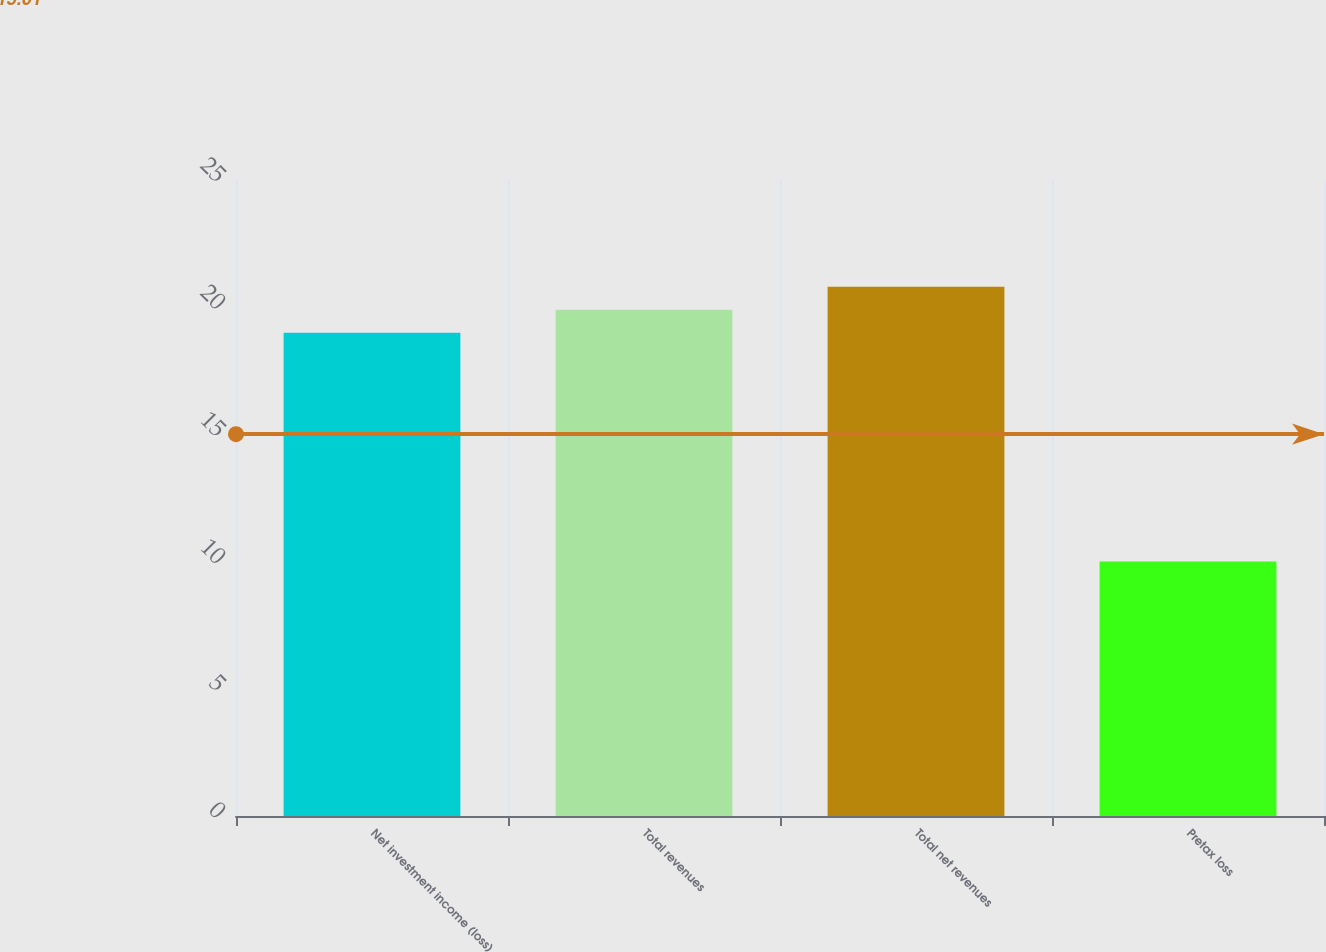Convert chart. <chart><loc_0><loc_0><loc_500><loc_500><bar_chart><fcel>Net investment income (loss)<fcel>Total revenues<fcel>Total net revenues<fcel>Pretax loss<nl><fcel>19<fcel>19.9<fcel>20.8<fcel>10<nl></chart> 